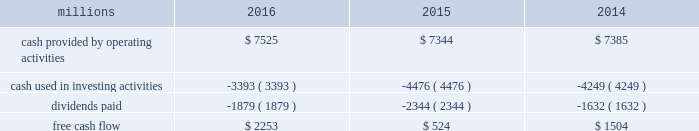To , rather than as a substitute for , cash provided by operating activities .
The table reconciles cash provided by operating activities ( gaap measure ) to free cash flow ( non-gaap measure ) : .
2017 outlook f0b7 safety 2013 operating a safe railroad benefits all our constituents : our employees , customers , shareholders and the communities we serve .
We will continue using a multi-faceted approach to safety , utilizing technology , risk assessment , training and employee engagement , quality control , and targeted capital investments .
We will continue using and expanding the deployment of total safety culture and courage to care throughout our operations , which allows us to identify and implement best practices for employee and operational safety .
We will continue our efforts to increase detection of rail defects ; improve or close crossings ; and educate the public and law enforcement agencies about crossing safety through a combination of our own programs ( including risk assessment strategies ) , industry programs and local community activities across our network .
F0b7 network operations 2013 in 2017 , we will continue to align resources with customer demand , maintain an efficient network , and ensure surge capability with our assets .
F0b7 fuel prices 2013 fuel price projections for crude oil and natural gas continue to fluctuate in the current environment .
We again could see volatile fuel prices during the year , as they are sensitive to global and u.s .
Domestic demand , refining capacity , geopolitical events , weather conditions and other factors .
As prices fluctuate , there will be a timing impact on earnings , as our fuel surcharge programs trail increases or decreases in fuel price by approximately two months .
Continuing lower fuel prices could have a positive impact on the economy by increasing consumer discretionary spending that potentially could increase demand for various consumer products that we transport .
Alternatively , lower fuel prices could likely have a negative impact on other commodities such as coal and domestic drilling-related shipments .
F0b7 capital plan 2013 in 2017 , we expect our capital plan to be approximately $ 3.1 billion , including expenditures for ptc , approximately 60 locomotives scheduled to be delivered , and intermodal containers and chassis , and freight cars .
The capital plan may be revised if business conditions warrant or if new laws or regulations affect our ability to generate sufficient returns on these investments .
( see further discussion in this item 7 under liquidity and capital resources 2013 capital plan. ) f0b7 financial expectations 2013 economic conditions in many of our market sectors continue to drive uncertainty with respect to our volume levels .
We expect volume to grow in the low single digit range in 2017 compared to 2016 , but it will depend on the overall economy and market conditions .
One of the more significant uncertainties is the outlook for energy markets , which will bring both challenges and opportunities .
In the current environment , we expect continued margin improvement driven by continued pricing opportunities , ongoing productivity initiatives , and the ability to leverage our resources and strengthen our franchise .
Over the longer term , we expect the overall u.s .
Economy to continue to improve at a modest pace , with some markets outperforming others. .
What was the percentage increase in the cash provided by operating activities from 2015 to 2016? 
Computations: ((7525 - 7344) / 7344)
Answer: 0.02465. 